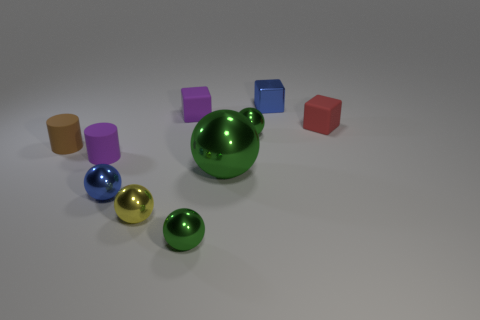There is a yellow metallic object that is the same shape as the big green thing; what is its size?
Keep it short and to the point. Small. Is the number of objects to the right of the small red matte object less than the number of small metallic cubes?
Your answer should be compact. Yes. How big is the green object to the left of the big green ball?
Offer a very short reply. Small. What is the color of the other matte object that is the same shape as the brown object?
Your answer should be very brief. Purple. How many other balls are the same color as the big sphere?
Ensure brevity in your answer.  2. Is there anything else that is the same shape as the tiny yellow metal thing?
Your answer should be very brief. Yes. Are there any tiny red matte objects that are on the left side of the small purple thing that is in front of the matte cube behind the red object?
Provide a succinct answer. No. What number of small things have the same material as the tiny red cube?
Offer a very short reply. 3. Is the size of the cylinder to the right of the brown cylinder the same as the blue thing that is left of the small blue block?
Offer a terse response. Yes. The small block right of the blue thing behind the tiny block that is on the right side of the small blue shiny block is what color?
Provide a succinct answer. Red. 